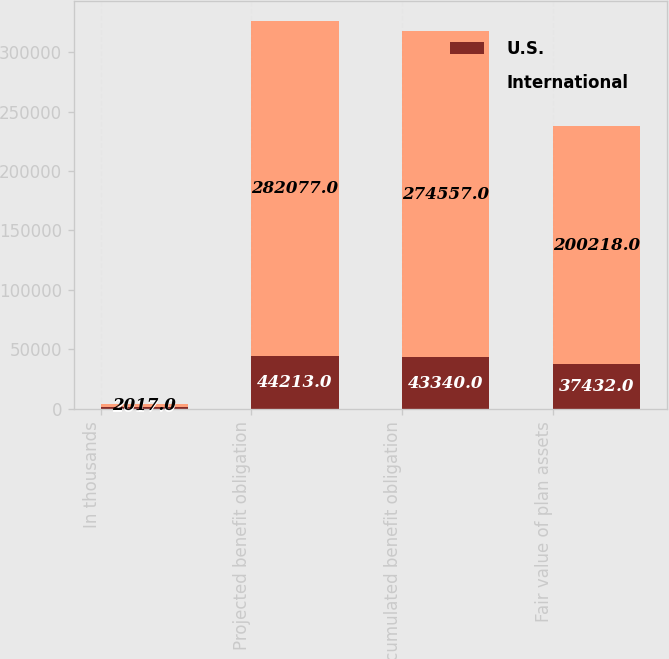Convert chart. <chart><loc_0><loc_0><loc_500><loc_500><stacked_bar_chart><ecel><fcel>In thousands<fcel>Projected benefit obligation<fcel>Accumulated benefit obligation<fcel>Fair value of plan assets<nl><fcel>U.S.<fcel>2017<fcel>44213<fcel>43340<fcel>37432<nl><fcel>International<fcel>2017<fcel>282077<fcel>274557<fcel>200218<nl></chart> 